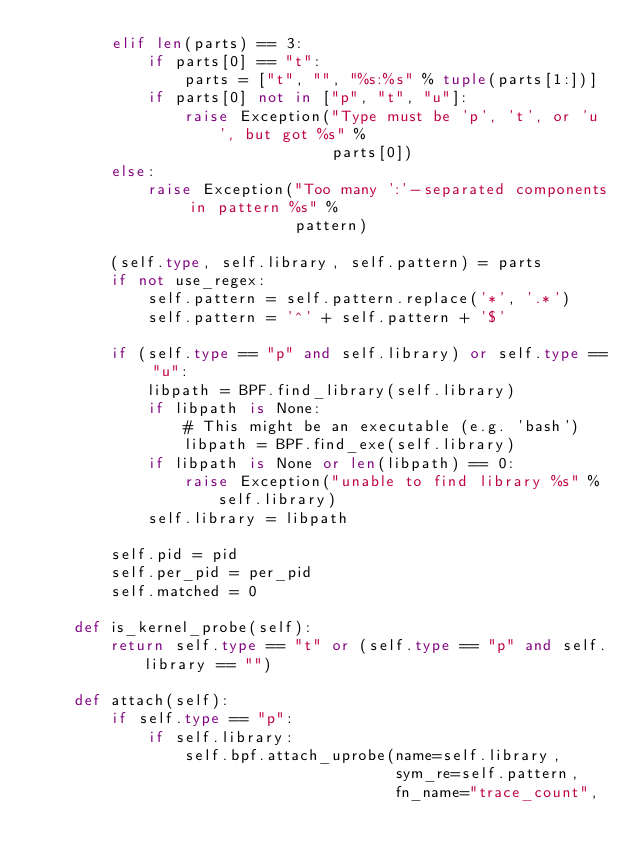<code> <loc_0><loc_0><loc_500><loc_500><_Python_>        elif len(parts) == 3:
            if parts[0] == "t":
                parts = ["t", "", "%s:%s" % tuple(parts[1:])]
            if parts[0] not in ["p", "t", "u"]:
                raise Exception("Type must be 'p', 't', or 'u', but got %s" %
                                parts[0])
        else:
            raise Exception("Too many ':'-separated components in pattern %s" %
                            pattern)

        (self.type, self.library, self.pattern) = parts
        if not use_regex:
            self.pattern = self.pattern.replace('*', '.*')
            self.pattern = '^' + self.pattern + '$'

        if (self.type == "p" and self.library) or self.type == "u":
            libpath = BPF.find_library(self.library)
            if libpath is None:
                # This might be an executable (e.g. 'bash')
                libpath = BPF.find_exe(self.library)
            if libpath is None or len(libpath) == 0:
                raise Exception("unable to find library %s" % self.library)
            self.library = libpath

        self.pid = pid
        self.per_pid = per_pid
        self.matched = 0

    def is_kernel_probe(self):
        return self.type == "t" or (self.type == "p" and self.library == "")

    def attach(self):
        if self.type == "p":
            if self.library:
                self.bpf.attach_uprobe(name=self.library,
                                       sym_re=self.pattern,
                                       fn_name="trace_count",</code> 